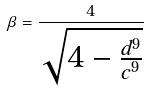<formula> <loc_0><loc_0><loc_500><loc_500>\beta = \frac { 4 } { \sqrt { 4 - \frac { d ^ { 9 } } { c ^ { 9 } } } }</formula> 